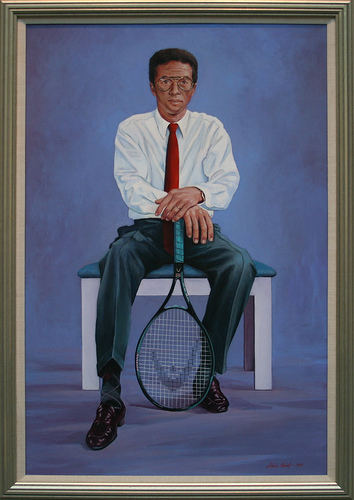Imagine the man is in the middle of a lively tennis match. Describe the scene. In the midst of a lively tennis match, the man grips the racket with intensity, his eyes focused on the approaching ball. The crowd around him roars with excitement, and the court is filled with tension. The blue background transforms into a vibrant tennis court under bright lights, with opponents and fans creating a dynamic and exhilarating atmosphere. 